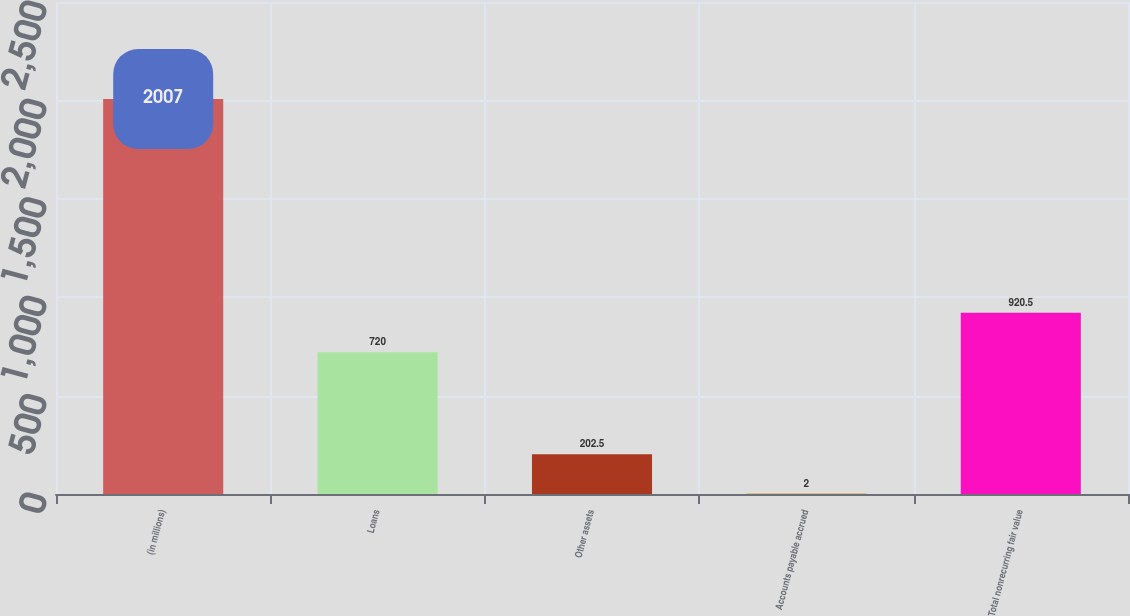<chart> <loc_0><loc_0><loc_500><loc_500><bar_chart><fcel>(in millions)<fcel>Loans<fcel>Other assets<fcel>Accounts payable accrued<fcel>Total nonrecurring fair value<nl><fcel>2007<fcel>720<fcel>202.5<fcel>2<fcel>920.5<nl></chart> 